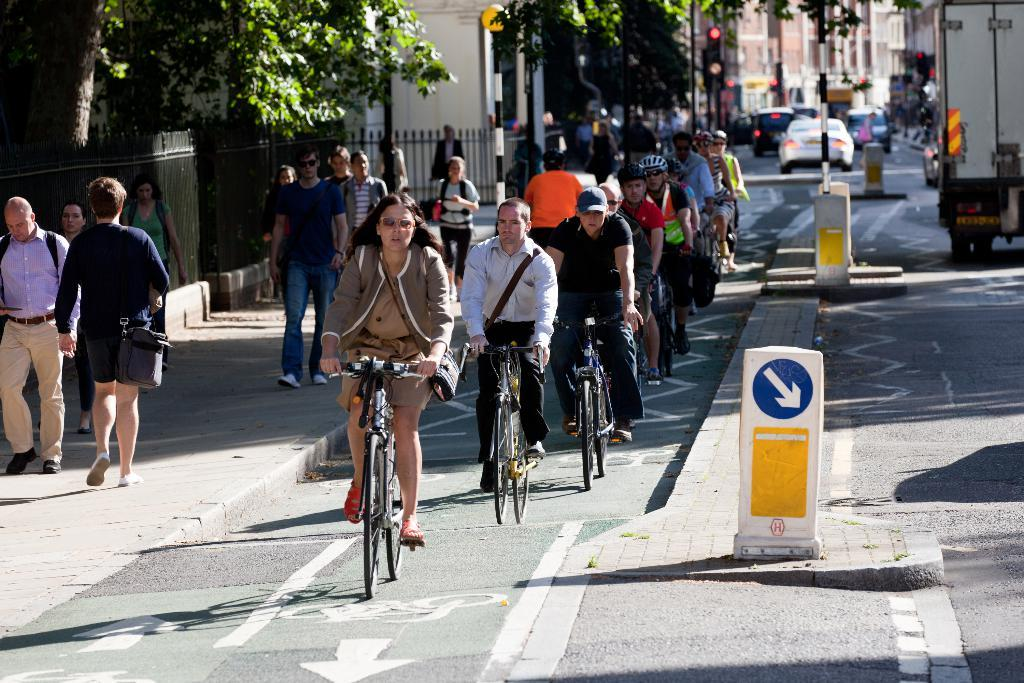How many people are in the image? There are people in the image, but the exact number is not specified. What are some of the people doing in the image? Some of the people are cycling in the image. What can be seen in the background of the image? There are trees, vehicles, and buildings in the background of the image. What type of throat lozenges can be seen in the image? There is no mention of throat lozenges in the image, so it is not possible to answer that question. 